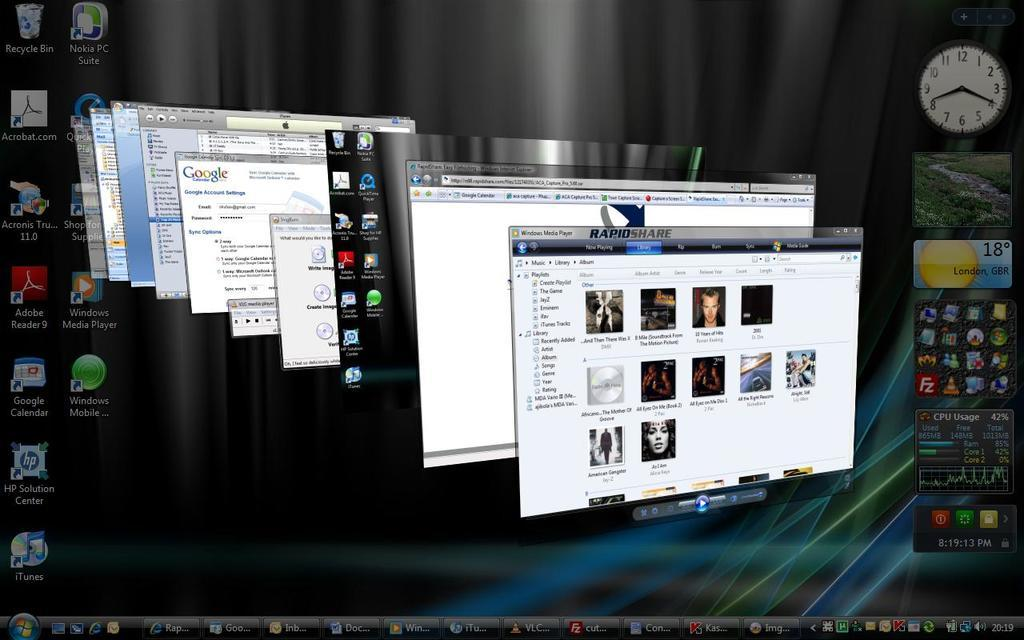<image>
Give a short and clear explanation of the subsequent image. A windows computer has the RapidShare program open. 